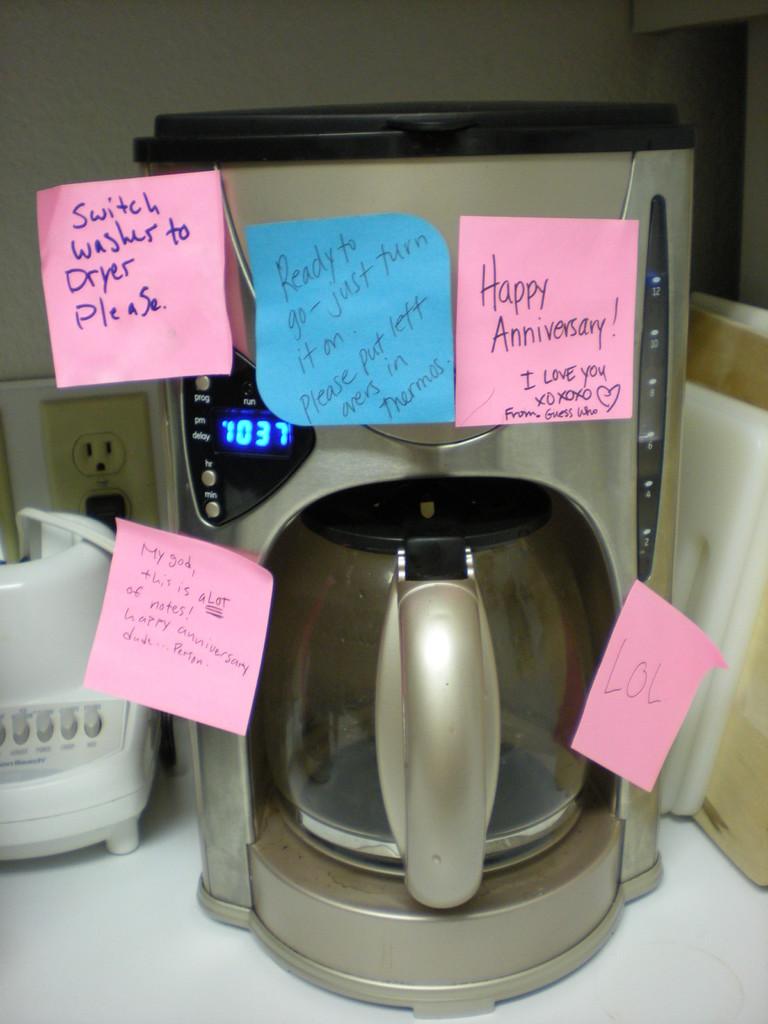What setting does the washer need to be set to?
Your answer should be very brief. Dryer. What special occassion is listed?
Provide a short and direct response. Anniversary. 